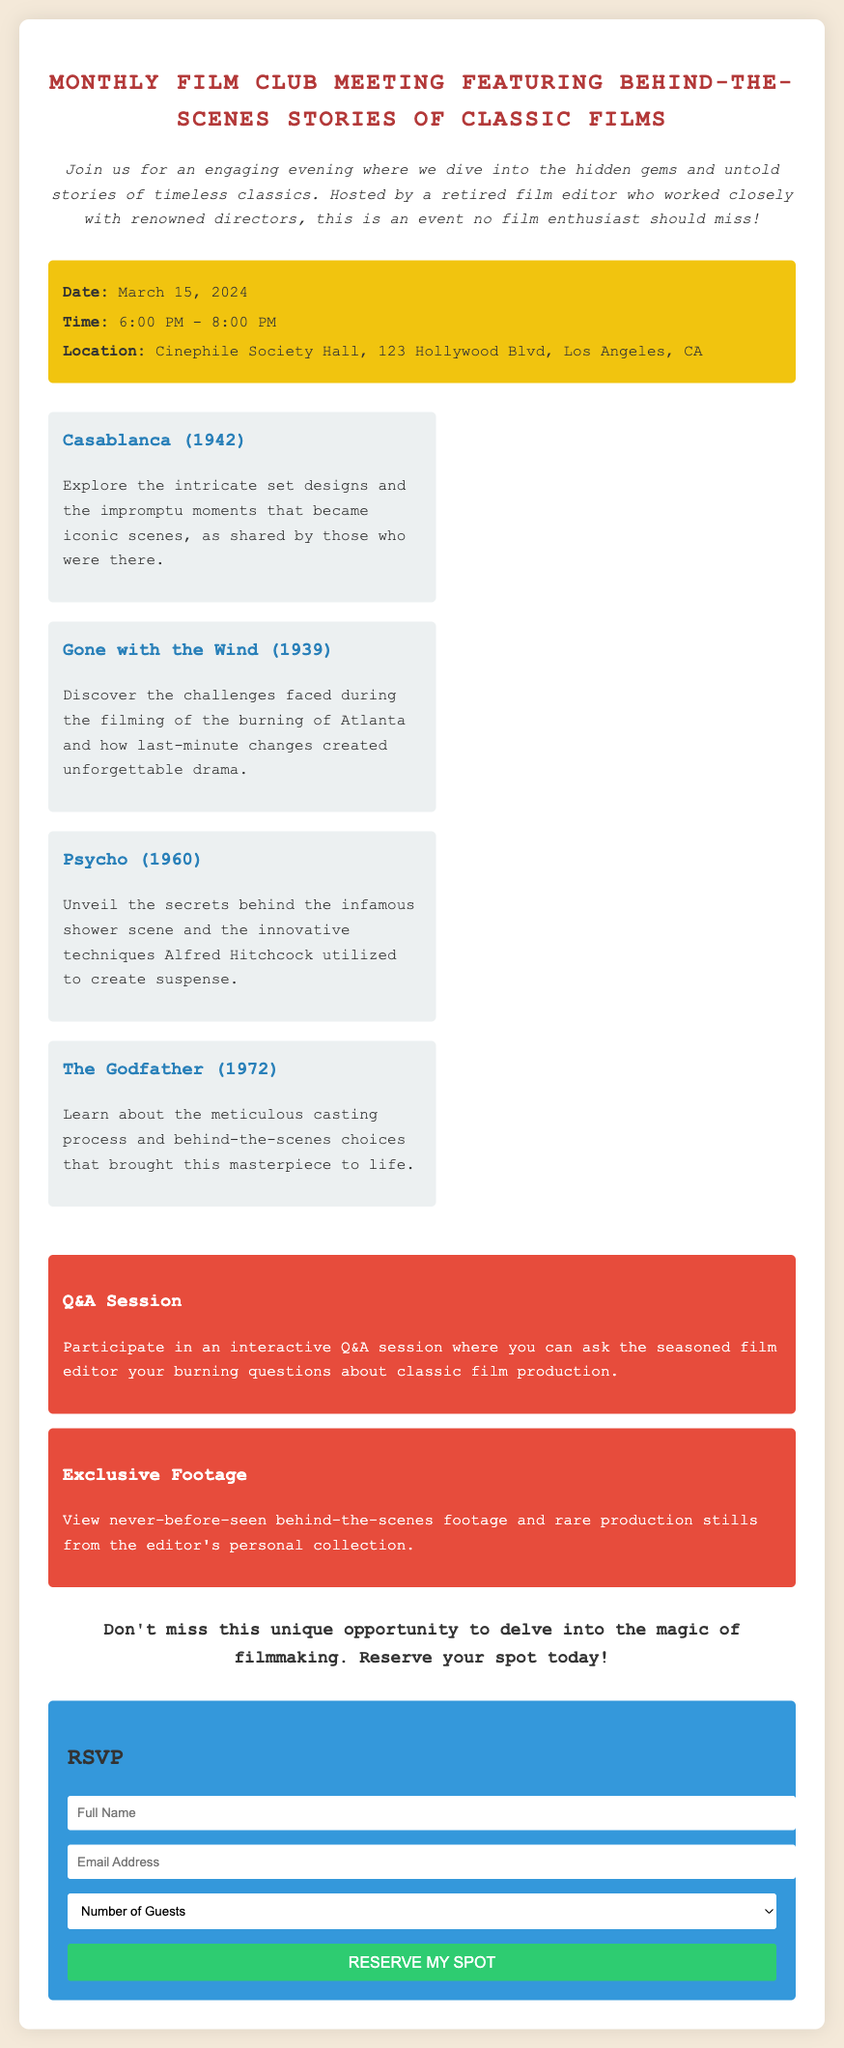What is the date of the meeting? The date of the meeting is mentioned in the event details section of the document.
Answer: March 15, 2024 What time does the event start? The document specifies the time in the event details section.
Answer: 6:00 PM Where is the meeting located? The location is clearly stated in the event details section of the document.
Answer: Cinephile Society Hall, 123 Hollywood Blvd, Los Angeles, CA How many films are featured in the meeting? The document lists four films under the featured films section.
Answer: Four What unique feature allows participants to ask questions? The document indicates a specific feature for interaction with the film editor.
Answer: Q&A Session What kind of footage will be shown during the meeting? The type of footage is described under the special features section of the document.
Answer: Exclusive Footage What is the maximum number of guests that can be selected in the RSVP? The RSVP form lists options for guests in a dropdown menu.
Answer: 4 What is the primary subject matter of the meeting? The introduction section describes the focus of the meeting.
Answer: Behind-the-Scenes Stories of Classic Films 